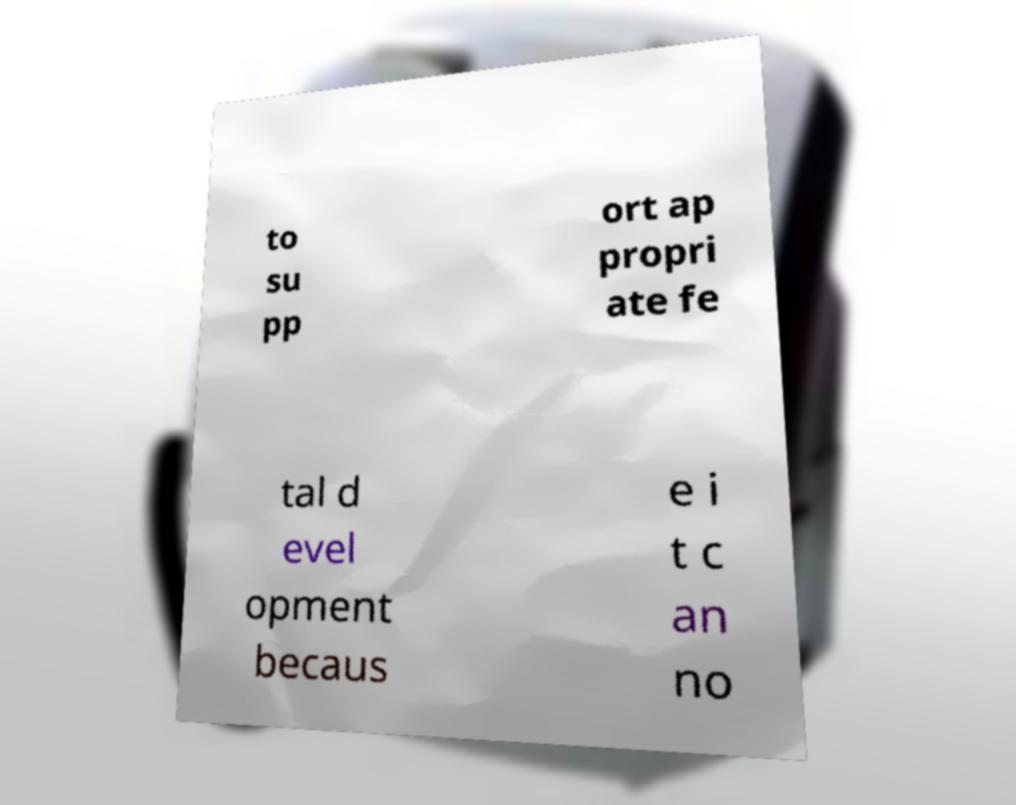What messages or text are displayed in this image? I need them in a readable, typed format. to su pp ort ap propri ate fe tal d evel opment becaus e i t c an no 